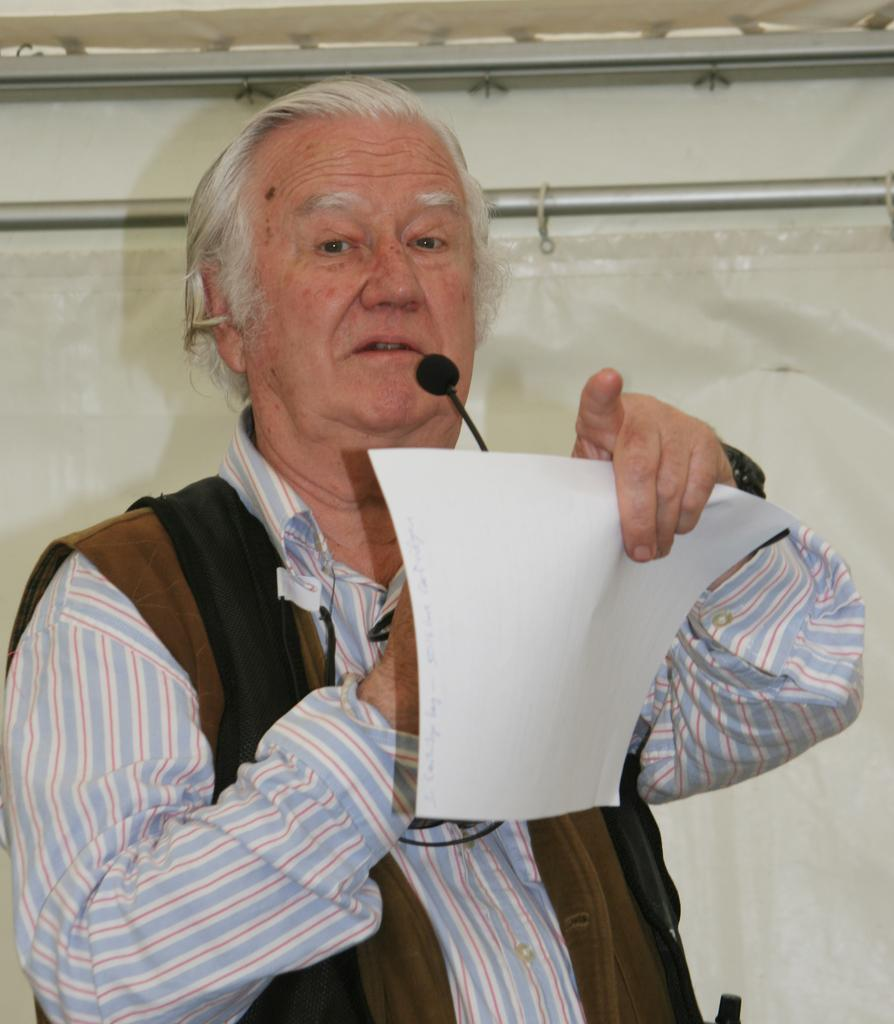What is the person in the image doing? The person is standing in the image. What is the person holding in the image? The person is holding a paper. What object can be seen near the person in the image? There is a microphone in the image. What is visible in the background of the image? There is a wall in the background of the image. Can you see any nerves in the image? There are no nerves visible in the image; it features a person standing with a paper and a microphone. Is there a playground in the image? There is no playground present in the image. 